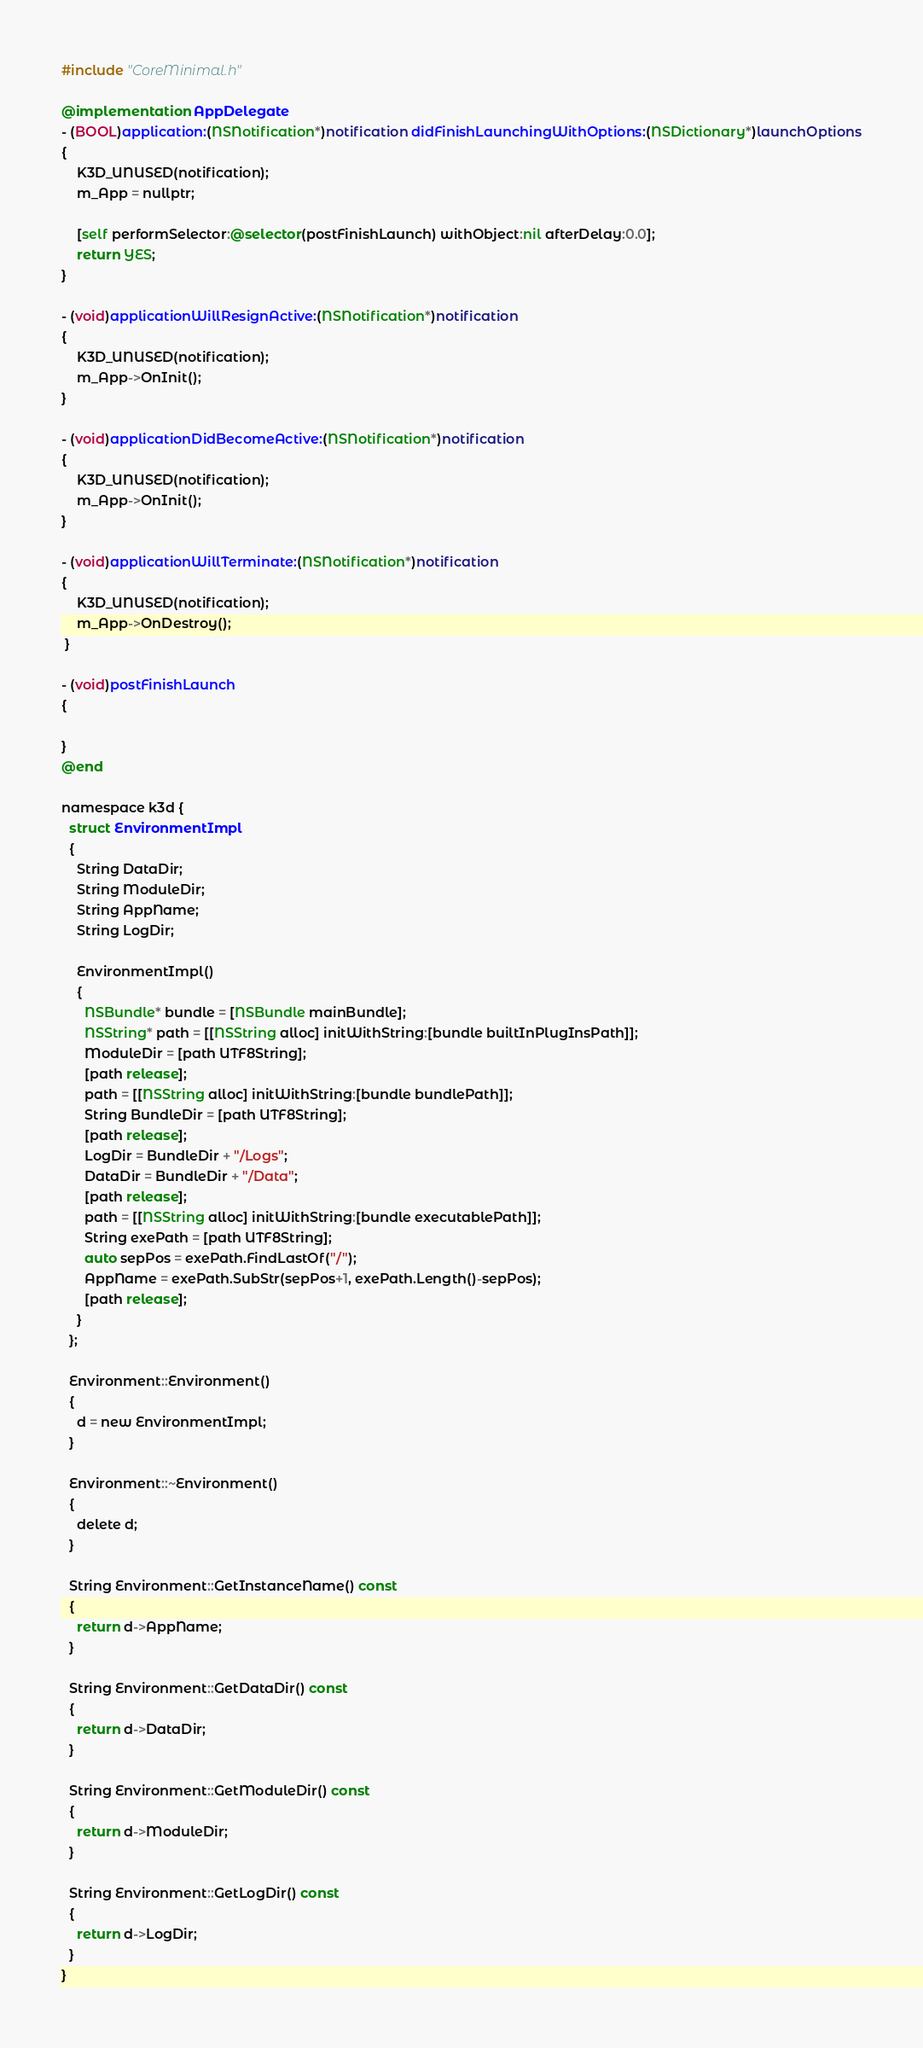<code> <loc_0><loc_0><loc_500><loc_500><_ObjectiveC_>#include "CoreMinimal.h"

@implementation AppDelegate
- (BOOL)application:(NSNotification*)notification didFinishLaunchingWithOptions:(NSDictionary*)launchOptions
{
    K3D_UNUSED(notification);
    m_App = nullptr;
    
    [self performSelector:@selector(postFinishLaunch) withObject:nil afterDelay:0.0];
    return YES;
}

- (void)applicationWillResignActive:(NSNotification*)notification
{
    K3D_UNUSED(notification);
    m_App->OnInit();
}

- (void)applicationDidBecomeActive:(NSNotification*)notification
{
    K3D_UNUSED(notification);
    m_App->OnInit();
}

- (void)applicationWillTerminate:(NSNotification*)notification
{
    K3D_UNUSED(notification);
    m_App->OnDestroy();
 }

- (void)postFinishLaunch
{

}
@end

namespace k3d {
  struct EnvironmentImpl
  {
    String DataDir;
    String ModuleDir;
    String AppName;
    String LogDir;
    
    EnvironmentImpl()
    {
      NSBundle* bundle = [NSBundle mainBundle];
      NSString* path = [[NSString alloc] initWithString:[bundle builtInPlugInsPath]];
      ModuleDir = [path UTF8String];
      [path release];
      path = [[NSString alloc] initWithString:[bundle bundlePath]];
      String BundleDir = [path UTF8String];
      [path release];
      LogDir = BundleDir + "/Logs";
      DataDir = BundleDir + "/Data";
      [path release];
      path = [[NSString alloc] initWithString:[bundle executablePath]];
      String exePath = [path UTF8String];
      auto sepPos = exePath.FindLastOf("/");
      AppName = exePath.SubStr(sepPos+1, exePath.Length()-sepPos);
      [path release];
    }
  };
  
  Environment::Environment()
  {
    d = new EnvironmentImpl;
  }
  
  Environment::~Environment()
  {
    delete d;
  }
  
  String Environment::GetInstanceName() const
  {
    return d->AppName;
  }
  
  String Environment::GetDataDir() const
  {
    return d->DataDir;
  }
  
  String Environment::GetModuleDir() const
  {
    return d->ModuleDir;
  }
  
  String Environment::GetLogDir() const
  {
    return d->LogDir;
  }
}
</code> 